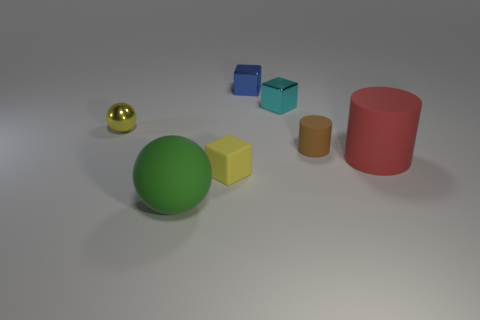Subtract all blocks. How many objects are left? 4 Add 1 yellow metal balls. How many objects exist? 8 Subtract all large green objects. Subtract all tiny balls. How many objects are left? 5 Add 1 big objects. How many big objects are left? 3 Add 7 green objects. How many green objects exist? 8 Subtract 0 red blocks. How many objects are left? 7 